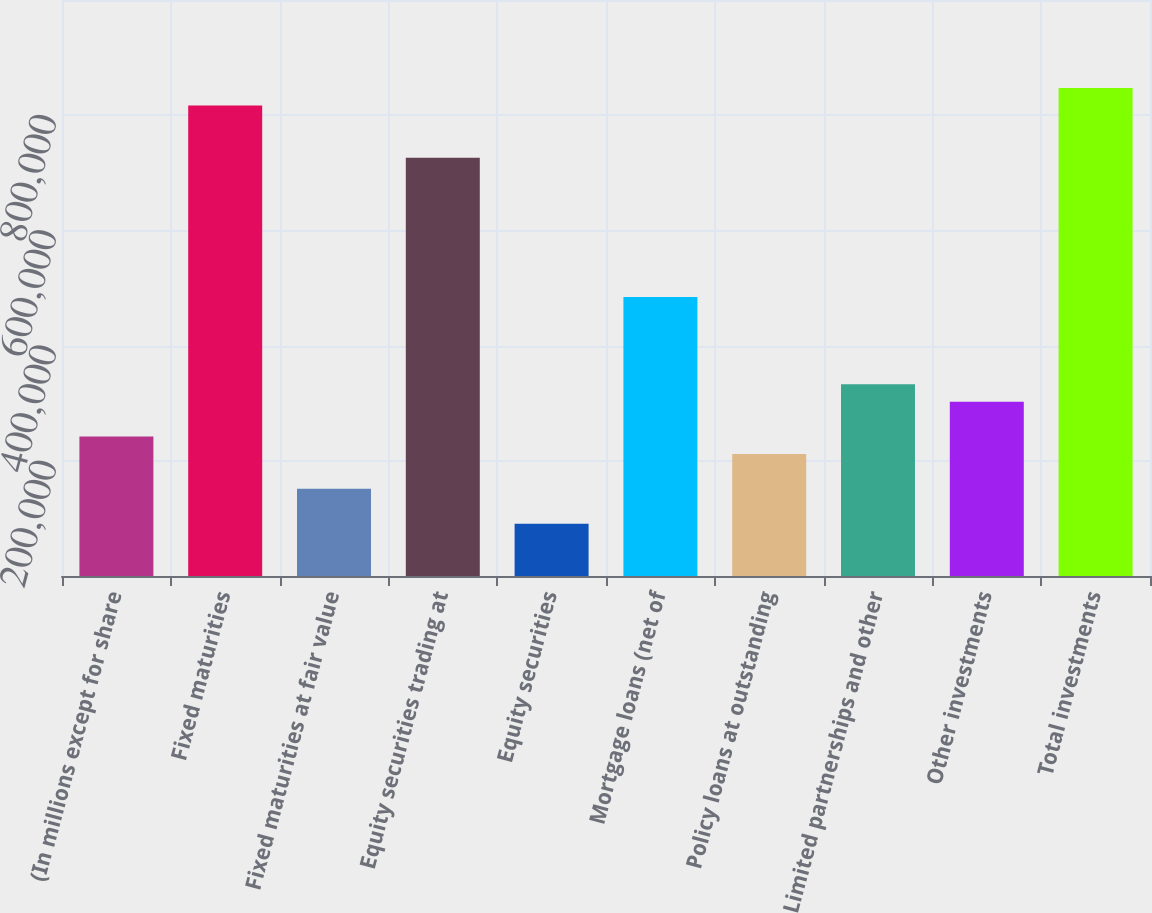Convert chart to OTSL. <chart><loc_0><loc_0><loc_500><loc_500><bar_chart><fcel>(In millions except for share<fcel>Fixed maturities<fcel>Fixed maturities at fair value<fcel>Equity securities trading at<fcel>Equity securities<fcel>Mortgage loans (net of<fcel>Policy loans at outstanding<fcel>Limited partnerships and other<fcel>Other investments<fcel>Total investments<nl><fcel>242088<fcel>817036<fcel>151307<fcel>726255<fcel>90786.2<fcel>484171<fcel>211828<fcel>332869<fcel>302609<fcel>847296<nl></chart> 